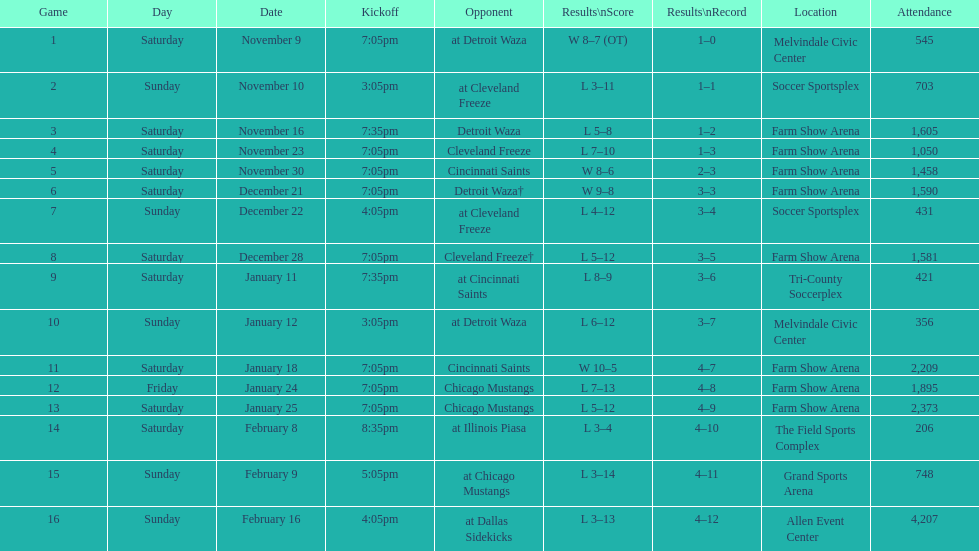Parse the full table. {'header': ['Game', 'Day', 'Date', 'Kickoff', 'Opponent', 'Results\\nScore', 'Results\\nRecord', 'Location', 'Attendance'], 'rows': [['1', 'Saturday', 'November 9', '7:05pm', 'at Detroit Waza', 'W 8–7 (OT)', '1–0', 'Melvindale Civic Center', '545'], ['2', 'Sunday', 'November 10', '3:05pm', 'at Cleveland Freeze', 'L 3–11', '1–1', 'Soccer Sportsplex', '703'], ['3', 'Saturday', 'November 16', '7:35pm', 'Detroit Waza', 'L 5–8', '1–2', 'Farm Show Arena', '1,605'], ['4', 'Saturday', 'November 23', '7:05pm', 'Cleveland Freeze', 'L 7–10', '1–3', 'Farm Show Arena', '1,050'], ['5', 'Saturday', 'November 30', '7:05pm', 'Cincinnati Saints', 'W 8–6', '2–3', 'Farm Show Arena', '1,458'], ['6', 'Saturday', 'December 21', '7:05pm', 'Detroit Waza†', 'W 9–8', '3–3', 'Farm Show Arena', '1,590'], ['7', 'Sunday', 'December 22', '4:05pm', 'at Cleveland Freeze', 'L 4–12', '3–4', 'Soccer Sportsplex', '431'], ['8', 'Saturday', 'December 28', '7:05pm', 'Cleveland Freeze†', 'L 5–12', '3–5', 'Farm Show Arena', '1,581'], ['9', 'Saturday', 'January 11', '7:35pm', 'at Cincinnati Saints', 'L 8–9', '3–6', 'Tri-County Soccerplex', '421'], ['10', 'Sunday', 'January 12', '3:05pm', 'at Detroit Waza', 'L 6–12', '3–7', 'Melvindale Civic Center', '356'], ['11', 'Saturday', 'January 18', '7:05pm', 'Cincinnati Saints', 'W 10–5', '4–7', 'Farm Show Arena', '2,209'], ['12', 'Friday', 'January 24', '7:05pm', 'Chicago Mustangs', 'L 7–13', '4–8', 'Farm Show Arena', '1,895'], ['13', 'Saturday', 'January 25', '7:05pm', 'Chicago Mustangs', 'L 5–12', '4–9', 'Farm Show Arena', '2,373'], ['14', 'Saturday', 'February 8', '8:35pm', 'at Illinois Piasa', 'L 3–4', '4–10', 'The Field Sports Complex', '206'], ['15', 'Sunday', 'February 9', '5:05pm', 'at Chicago Mustangs', 'L 3–14', '4–11', 'Grand Sports Arena', '748'], ['16', 'Sunday', 'February 16', '4:05pm', 'at Dallas Sidekicks', 'L 3–13', '4–12', 'Allen Event Center', '4,207']]} Who was the first opponent on this list? Detroit Waza. 